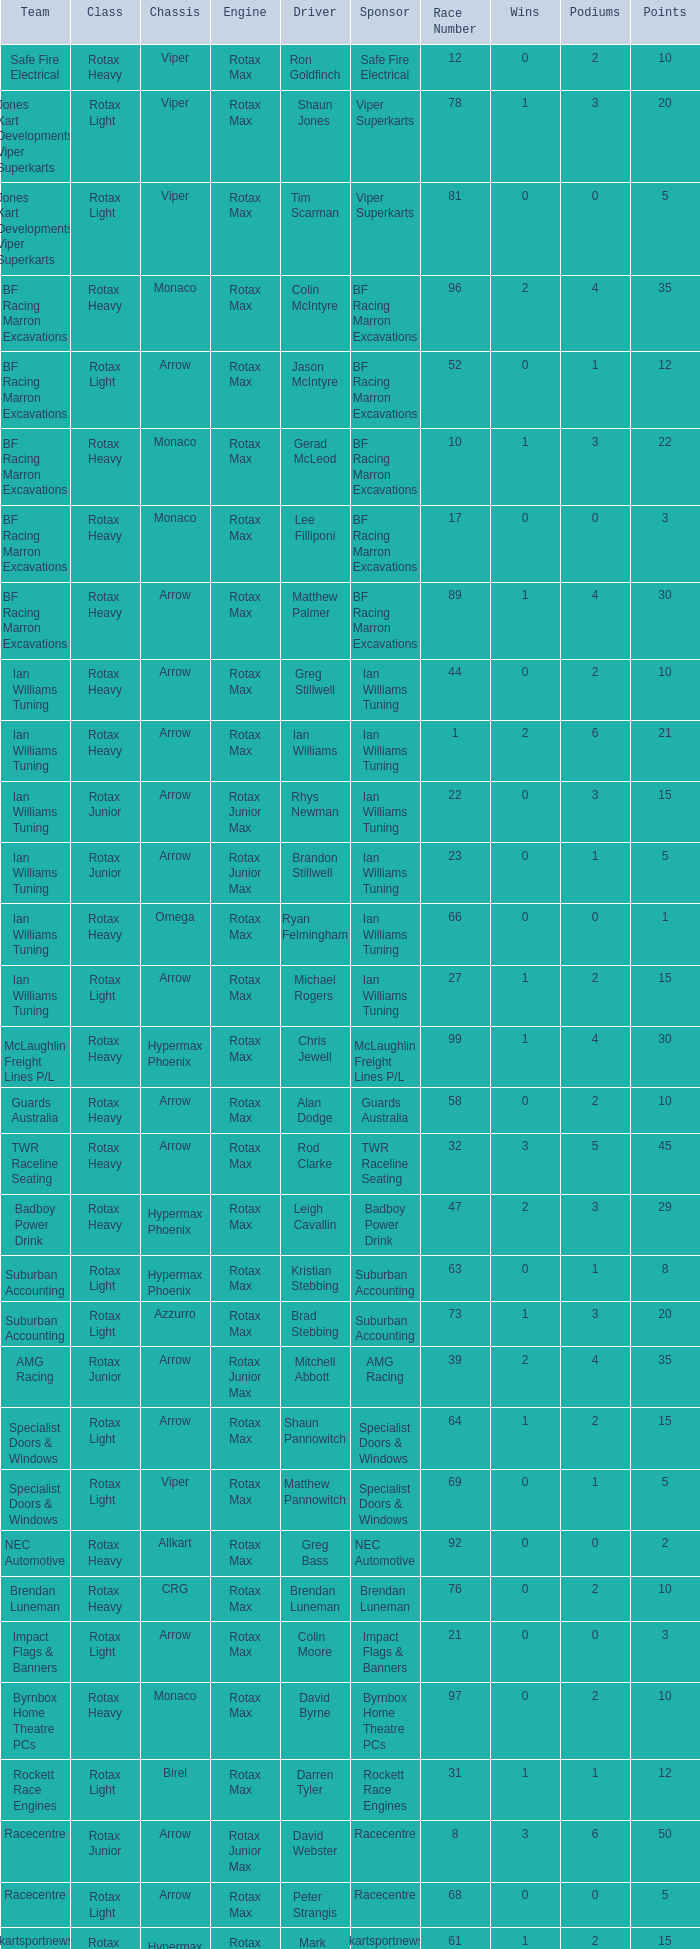Driver Shaun Jones with a viper as a chassis is in what class? Rotax Light. 